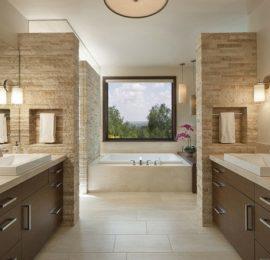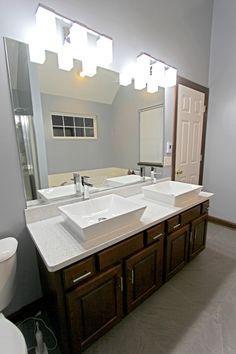The first image is the image on the left, the second image is the image on the right. Assess this claim about the two images: "The flowers in the vase are pink.". Correct or not? Answer yes or no. Yes. The first image is the image on the left, the second image is the image on the right. Examine the images to the left and right. Is the description "An image shows a vanity counter angled to the right with two separate white sinks sitting on top of the counter." accurate? Answer yes or no. Yes. 